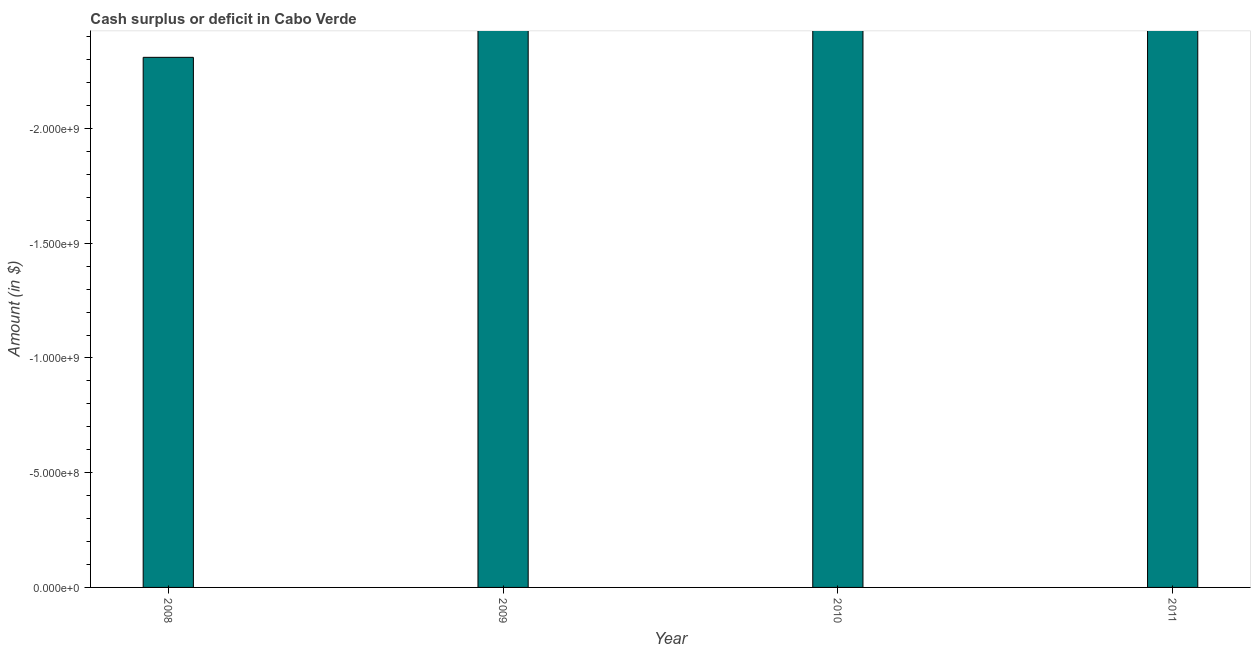What is the title of the graph?
Provide a short and direct response. Cash surplus or deficit in Cabo Verde. What is the label or title of the X-axis?
Your response must be concise. Year. What is the label or title of the Y-axis?
Make the answer very short. Amount (in $). How many bars are there?
Keep it short and to the point. 0. How many years are there in the graph?
Offer a very short reply. 4. What is the difference between two consecutive major ticks on the Y-axis?
Your response must be concise. 5.00e+08. Are the values on the major ticks of Y-axis written in scientific E-notation?
Offer a terse response. Yes. What is the Amount (in $) of 2008?
Your answer should be compact. 0. What is the Amount (in $) of 2011?
Your response must be concise. 0. 